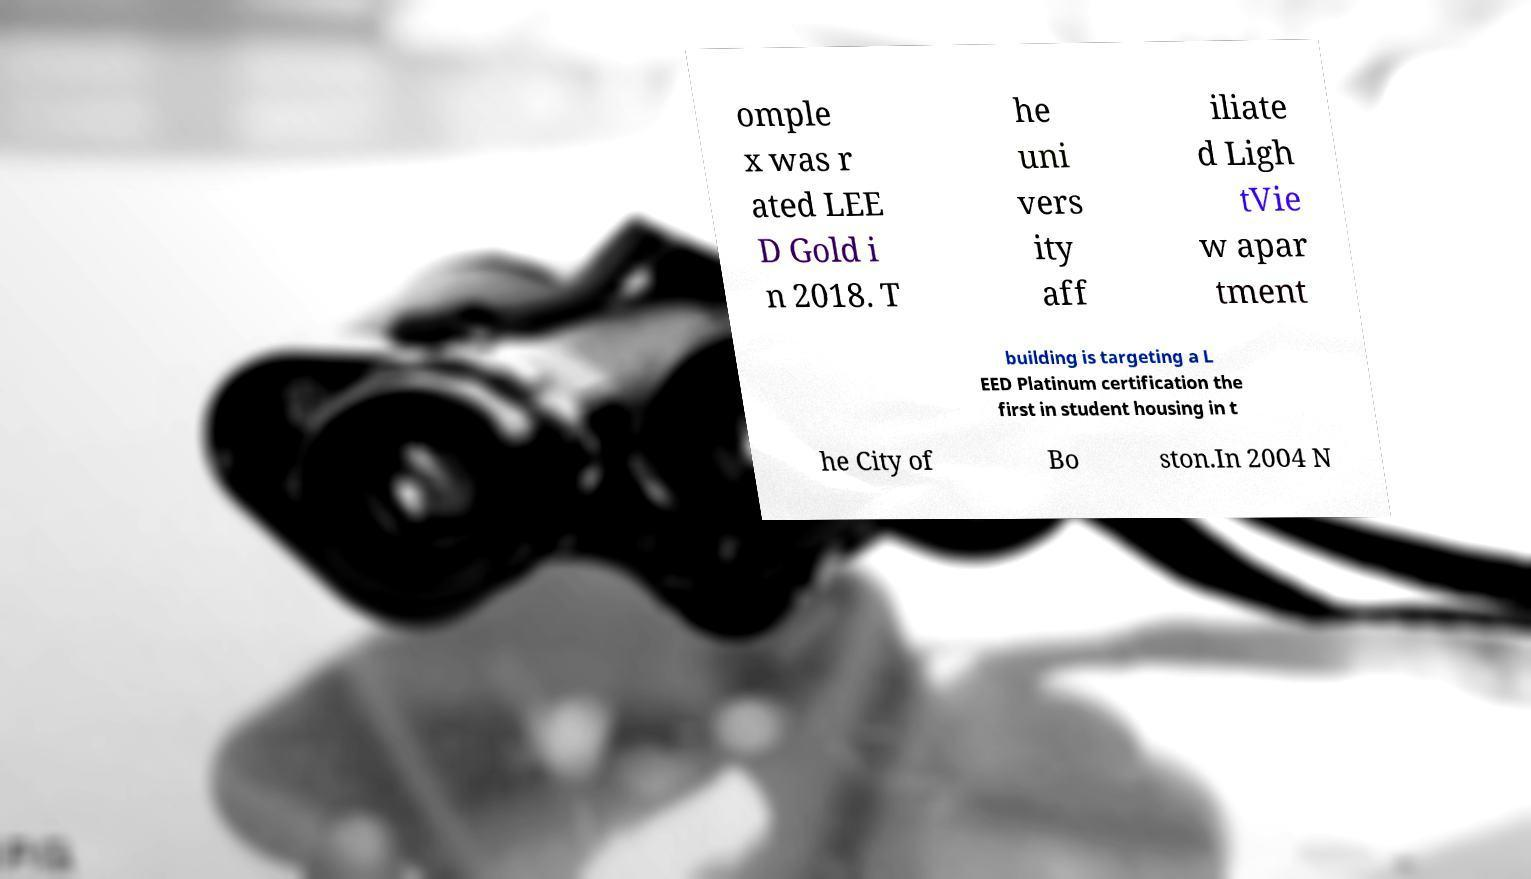What messages or text are displayed in this image? I need them in a readable, typed format. omple x was r ated LEE D Gold i n 2018. T he uni vers ity aff iliate d Ligh tVie w apar tment building is targeting a L EED Platinum certification the first in student housing in t he City of Bo ston.In 2004 N 